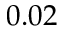<formula> <loc_0><loc_0><loc_500><loc_500>0 . 0 2</formula> 